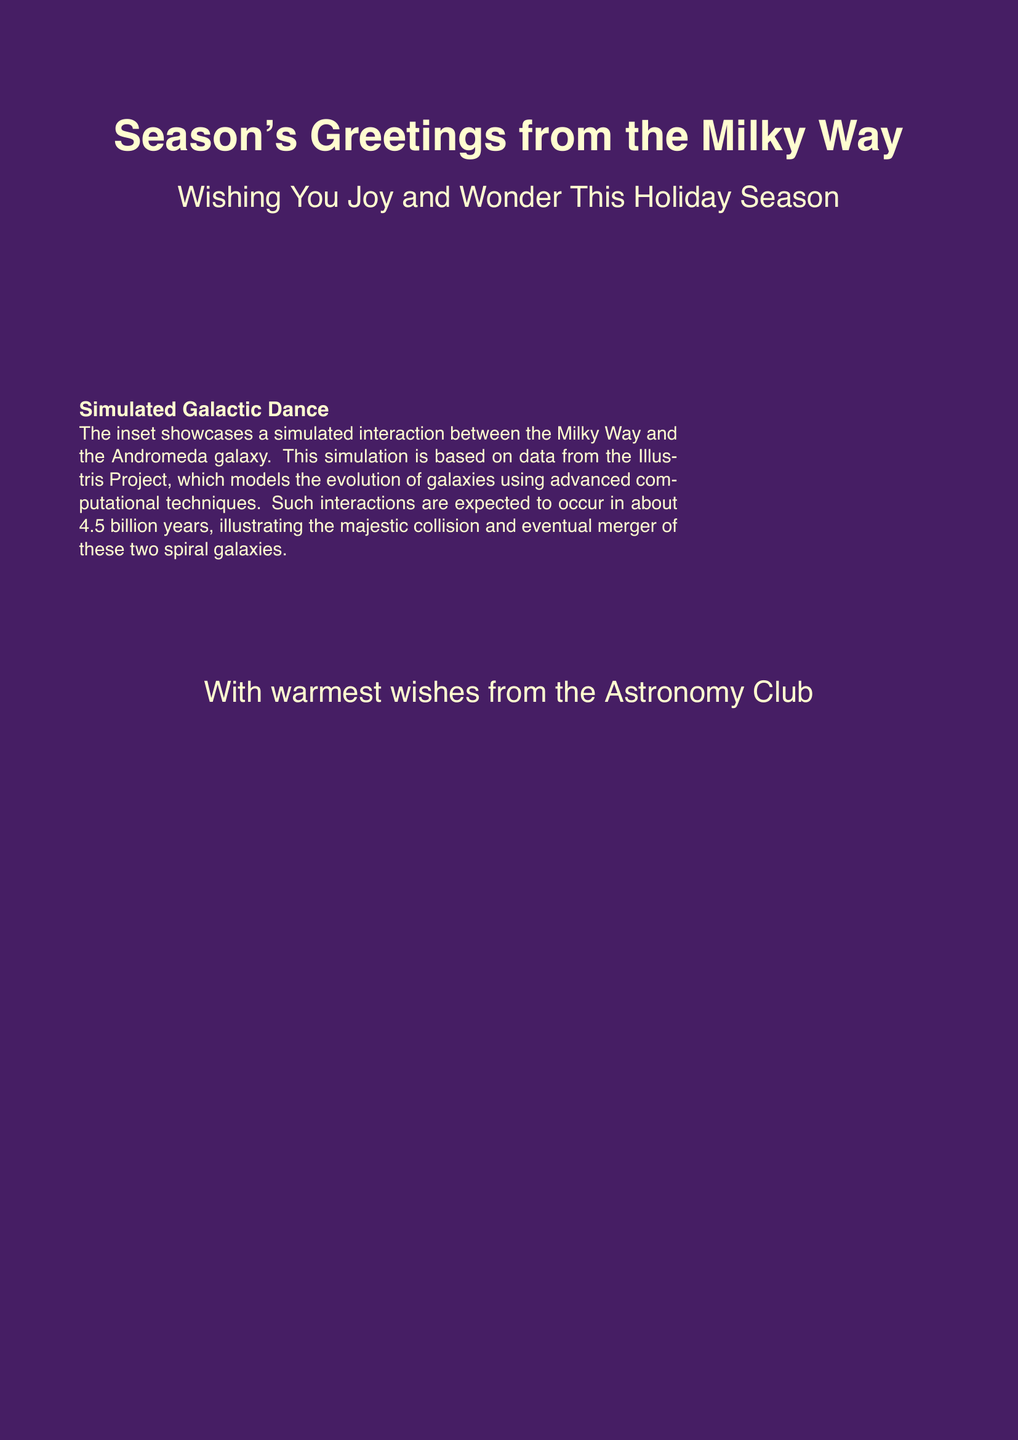What season does the card represent? The card features a holiday-themed greeting that represents the winter season.
Answer: Winter What galaxy is depicted in the artwork? The card showcases the Milky Way galaxy as the main focus of the artwork.
Answer: Milky Way How does the message describe the holiday season? The message wishes joy and wonder, reflecting a positive sentiment typical of festive greetings.
Answer: Joy and Wonder Which galaxy is interacting with the Milky Way in the inset? The inset of the card illustrates the Andromeda galaxy interacting with the Milky Way.
Answer: Andromeda What scientific project informs the simulation on the card? The simulation depicted in the inset is based on data from the Illustris Project.
Answer: Illustris Project How long until the Milky Way and Andromeda galaxies are expected to collide? The message states that the collision is expected to occur in approximately 4.5 billion years.
Answer: 4.5 billion years What color is used as the background of the card? The background color of the card is a shade referred to as space purple.
Answer: Space purple What is the name of the club sending the greeting? The greeting is sent on behalf of the Astronomy Club.
Answer: Astronomy Club 